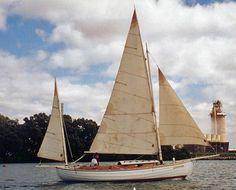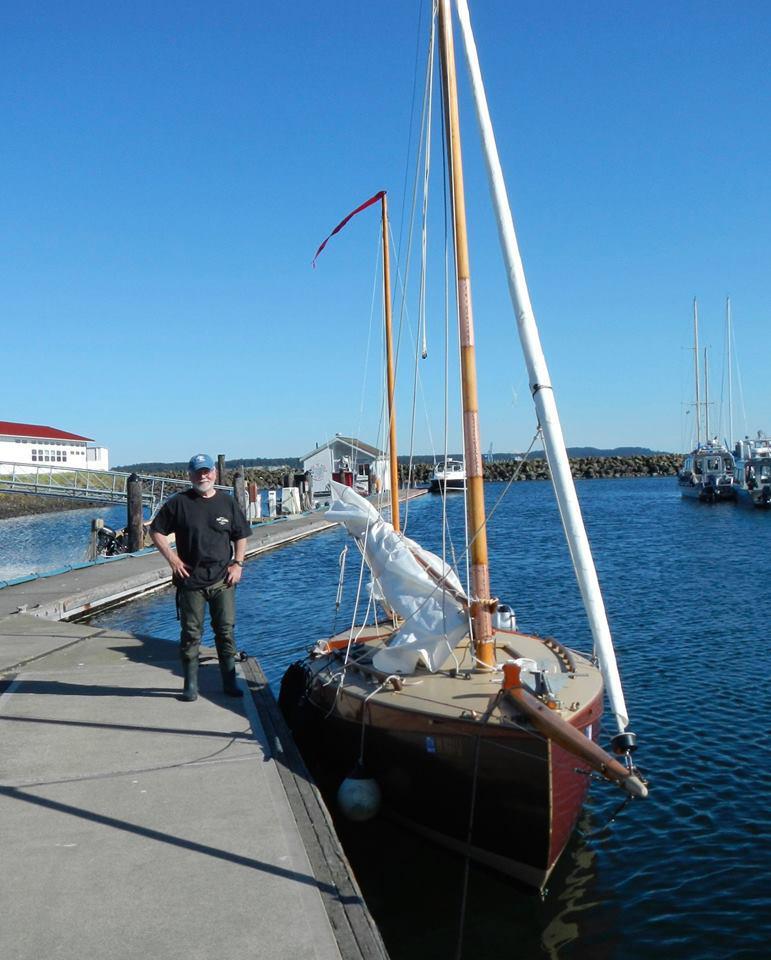The first image is the image on the left, the second image is the image on the right. Given the left and right images, does the statement "The left and right image contains the same number of sailboats with open sails." hold true? Answer yes or no. No. 